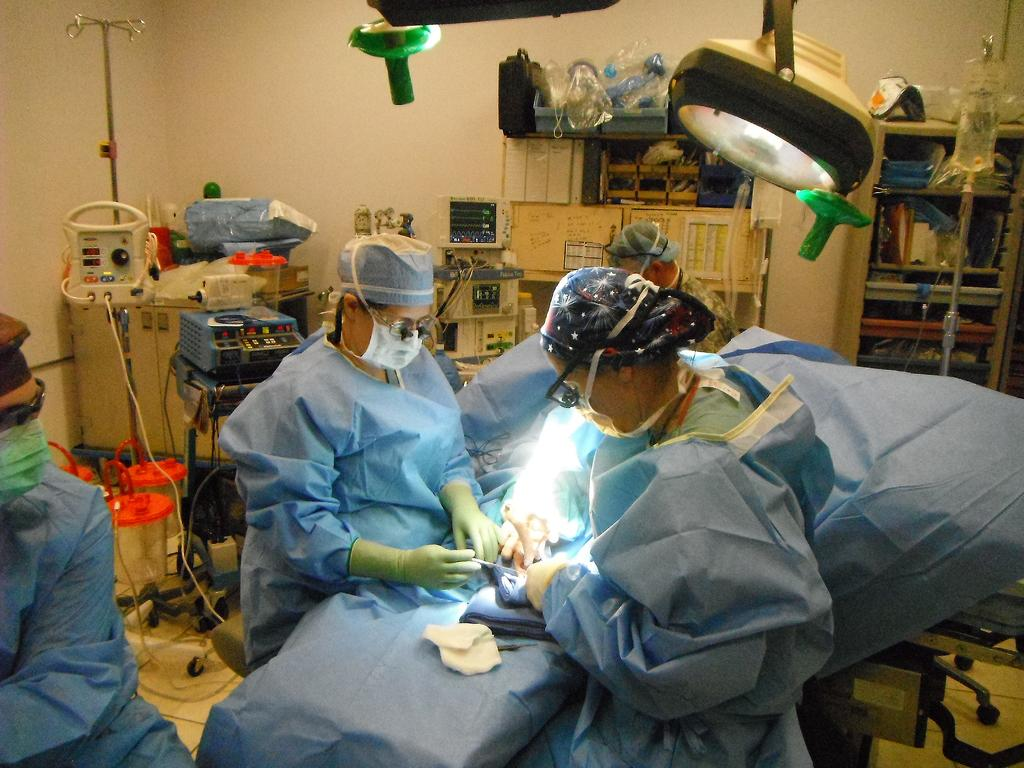How many people are the people in the image? There is a group of people in the image. What is located at the top of the image? There are surgical lights at the top of the image. What can be seen in the background of the image? There are equipments, a rack, a wall, and other unspecified objects in the background of the image. What type of bottle is being used for a chess game in the image? There is no bottle or chess game present in the image. 